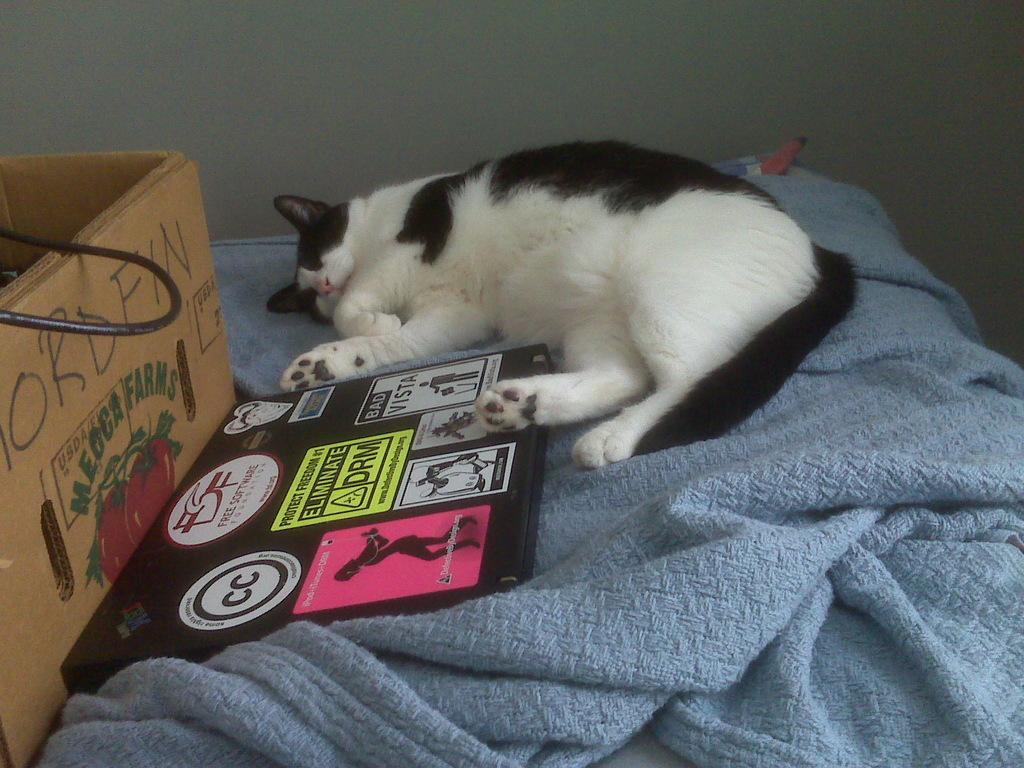Provide a one-sentence caption for the provided image. A cat sleeping on a bed next to a box from Meoca Farms. 